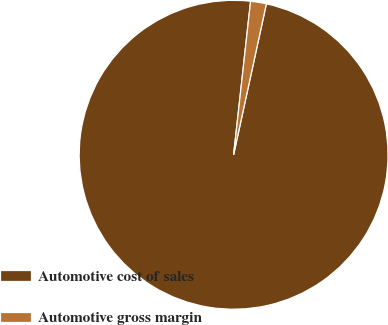<chart> <loc_0><loc_0><loc_500><loc_500><pie_chart><fcel>Automotive cost of sales<fcel>Automotive gross margin<nl><fcel>98.35%<fcel>1.65%<nl></chart> 